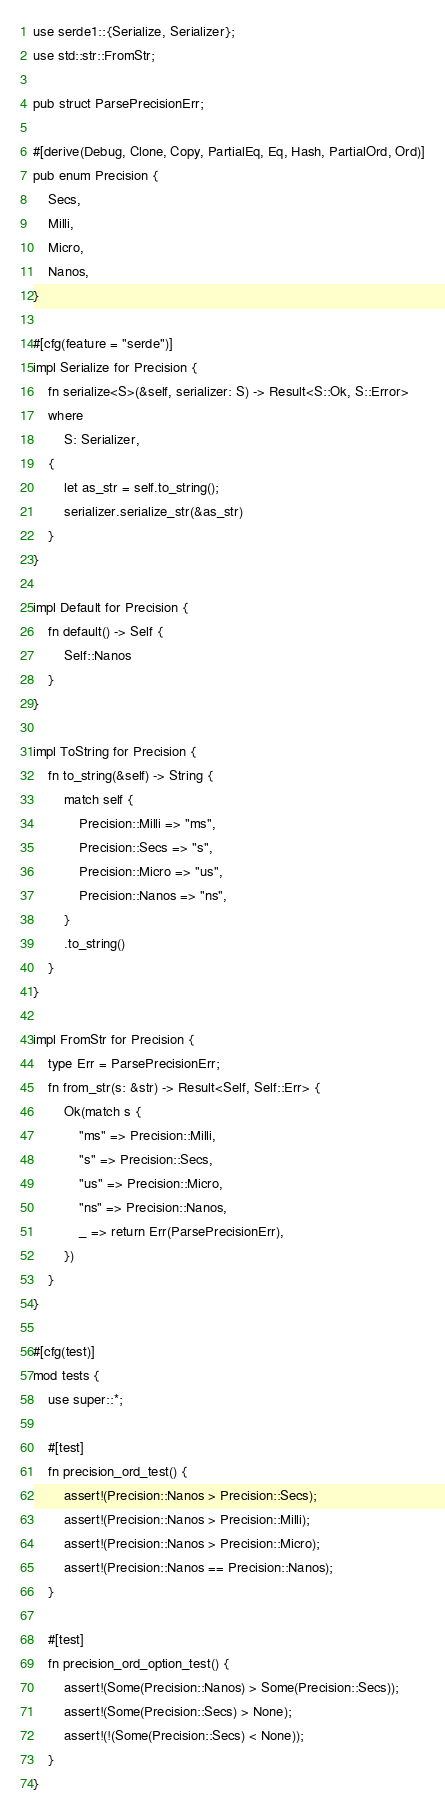Convert code to text. <code><loc_0><loc_0><loc_500><loc_500><_Rust_>use serde1::{Serialize, Serializer};
use std::str::FromStr;

pub struct ParsePrecisionErr;

#[derive(Debug, Clone, Copy, PartialEq, Eq, Hash, PartialOrd, Ord)]
pub enum Precision {
    Secs,
    Milli,
    Micro,
    Nanos,
}

#[cfg(feature = "serde")]
impl Serialize for Precision {
    fn serialize<S>(&self, serializer: S) -> Result<S::Ok, S::Error>
    where
        S: Serializer,
    {
        let as_str = self.to_string();
        serializer.serialize_str(&as_str)
    }
}

impl Default for Precision {
    fn default() -> Self {
        Self::Nanos
    }
}

impl ToString for Precision {
    fn to_string(&self) -> String {
        match self {
            Precision::Milli => "ms",
            Precision::Secs => "s",
            Precision::Micro => "us",
            Precision::Nanos => "ns",
        }
        .to_string()
    }
}

impl FromStr for Precision {
    type Err = ParsePrecisionErr;
    fn from_str(s: &str) -> Result<Self, Self::Err> {
        Ok(match s {
            "ms" => Precision::Milli,
            "s" => Precision::Secs,
            "us" => Precision::Micro,
            "ns" => Precision::Nanos,
            _ => return Err(ParsePrecisionErr),
        })
    }
}

#[cfg(test)]
mod tests {
    use super::*;

    #[test]
    fn precision_ord_test() {
        assert!(Precision::Nanos > Precision::Secs);
        assert!(Precision::Nanos > Precision::Milli);
        assert!(Precision::Nanos > Precision::Micro);
        assert!(Precision::Nanos == Precision::Nanos);
    }

    #[test]
    fn precision_ord_option_test() {
        assert!(Some(Precision::Nanos) > Some(Precision::Secs));
        assert!(Some(Precision::Secs) > None);
        assert!(!(Some(Precision::Secs) < None));
    }
}
</code> 